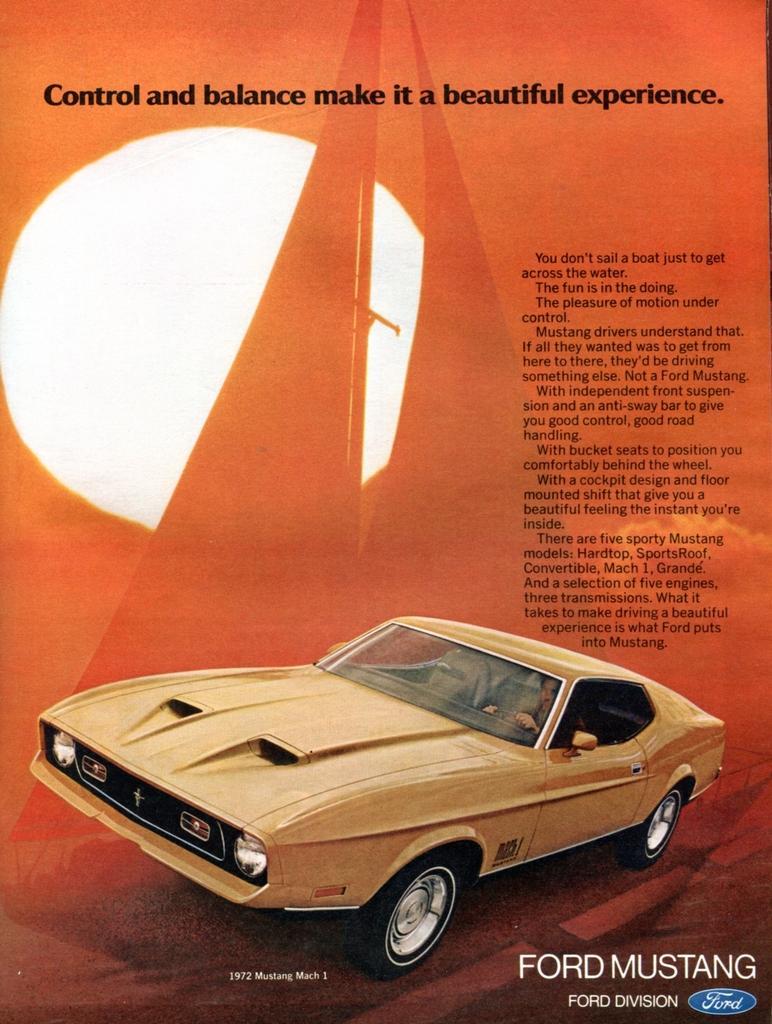Could you give a brief overview of what you see in this image? In this image I can see the car and the car is in brown color and I can see something written on the image and I can see an orange color background. 